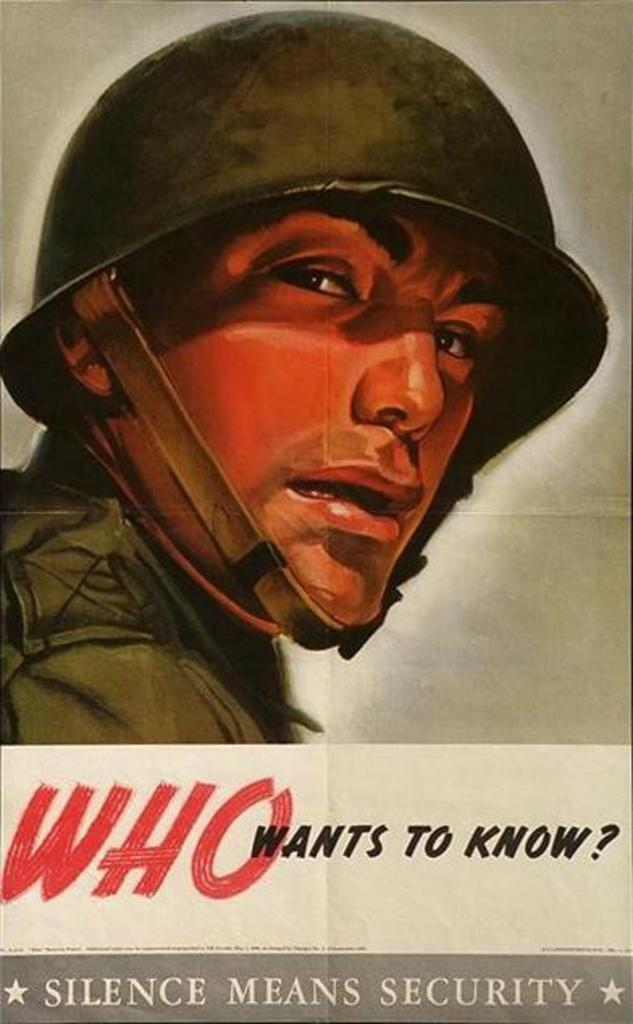<image>
Describe the image concisely. The drawing of a soldier appears on a sign that says Silence Means Security. 